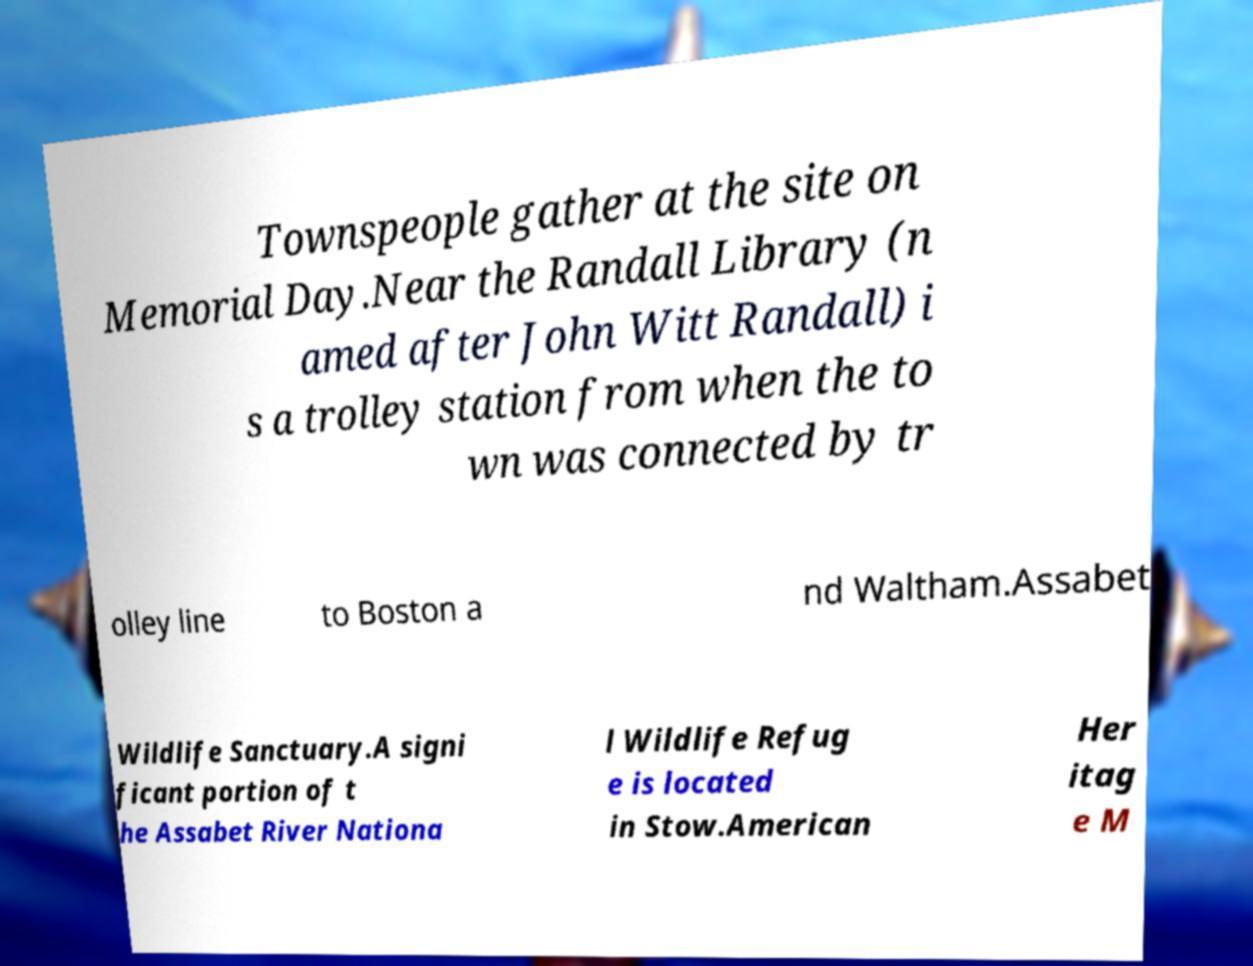Could you extract and type out the text from this image? Townspeople gather at the site on Memorial Day.Near the Randall Library (n amed after John Witt Randall) i s a trolley station from when the to wn was connected by tr olley line to Boston a nd Waltham.Assabet Wildlife Sanctuary.A signi ficant portion of t he Assabet River Nationa l Wildlife Refug e is located in Stow.American Her itag e M 